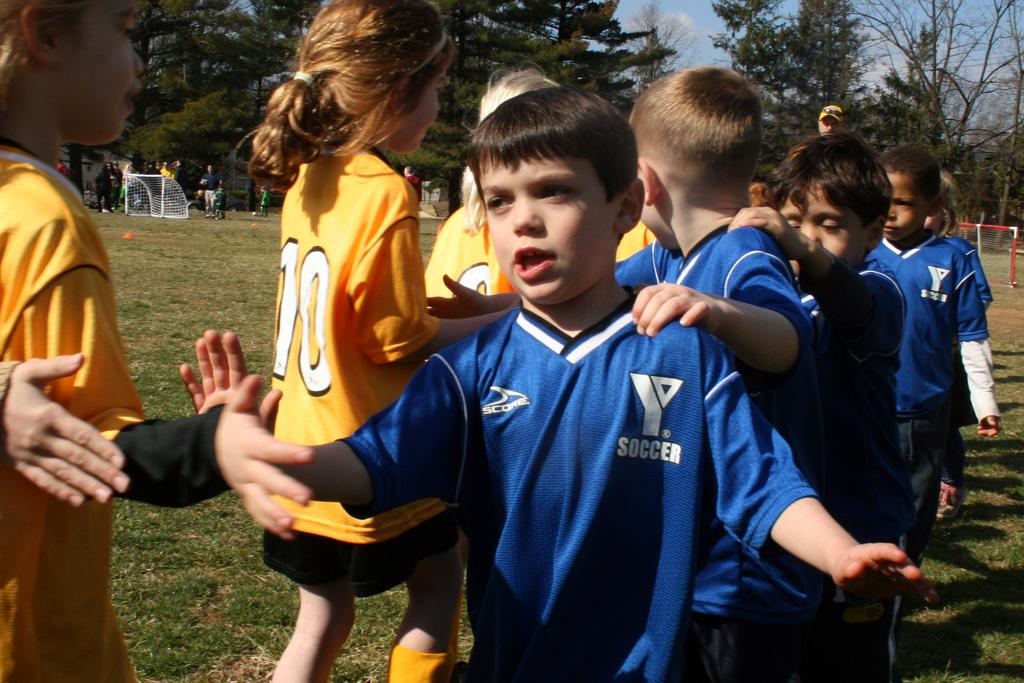<image>
Present a compact description of the photo's key features. Two youth soccer teams are lined up to high five each other. 